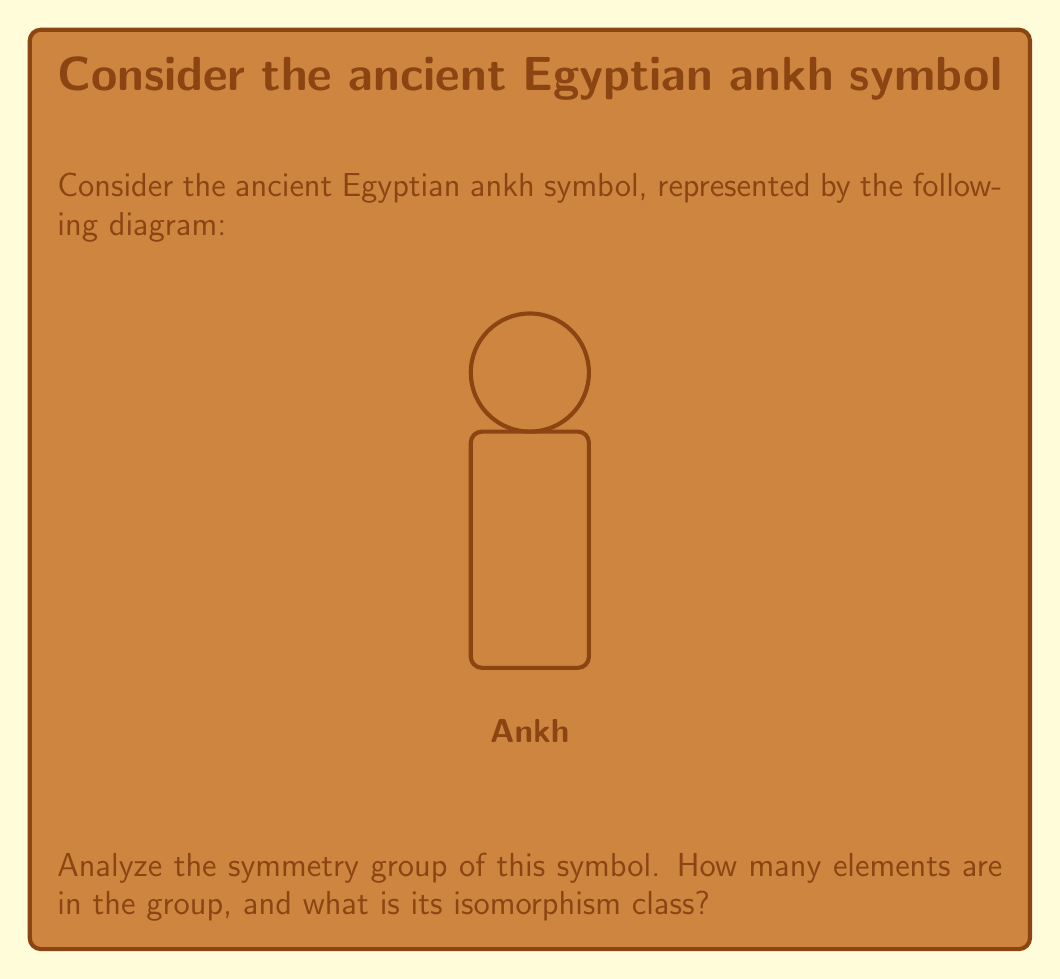Give your solution to this math problem. Let's approach this step-by-step:

1) First, we need to identify the symmetries of the ankh symbol:
   - Identity transformation (do nothing)
   - Reflection about the vertical axis

2) There are no rotational symmetries or other reflections that preserve the shape.

3) These two symmetries form a group under composition. Let's call the identity 'e' and the reflection 'r'.

4) The group table for this symmetry group is:

   | * | e | r |
   |---|---|---|
   | e | e | r |
   | r | r | e |

5) This group has order 2, as there are two elements.

6) To determine the isomorphism class, we need to consider groups of order 2. There is only one group of order 2 up to isomorphism: the cyclic group of order 2, denoted as $C_2$ or $\mathbb{Z}_2$.

7) Our symmetry group is indeed isomorphic to $C_2$, as it has the same structure: two elements, one of which is the identity, and the other is its own inverse.

8) In abstract algebra terms, this group is also isomorphic to the multiplicative group $\{1, -1\}$ under multiplication, often denoted as $\{\pm 1\}$.
Answer: 2 elements; isomorphic to $C_2$ 